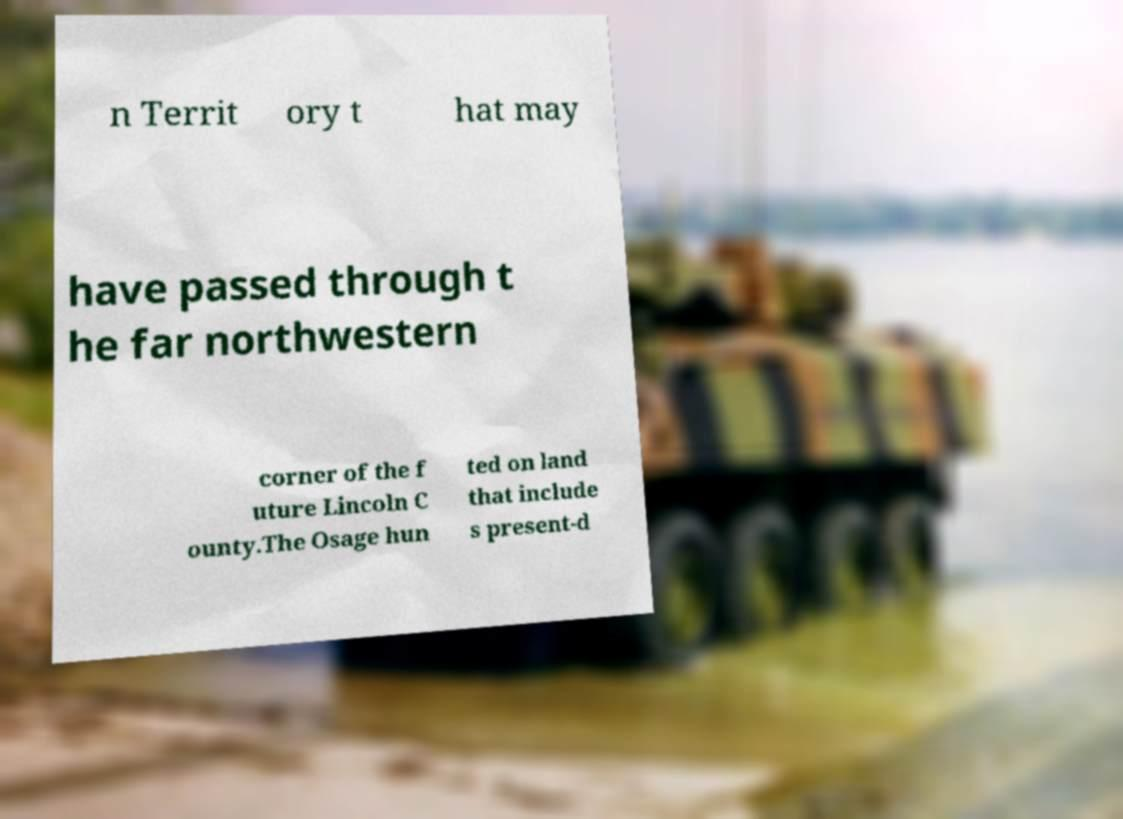Could you extract and type out the text from this image? n Territ ory t hat may have passed through t he far northwestern corner of the f uture Lincoln C ounty.The Osage hun ted on land that include s present-d 